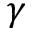Convert formula to latex. <formula><loc_0><loc_0><loc_500><loc_500>\gamma</formula> 